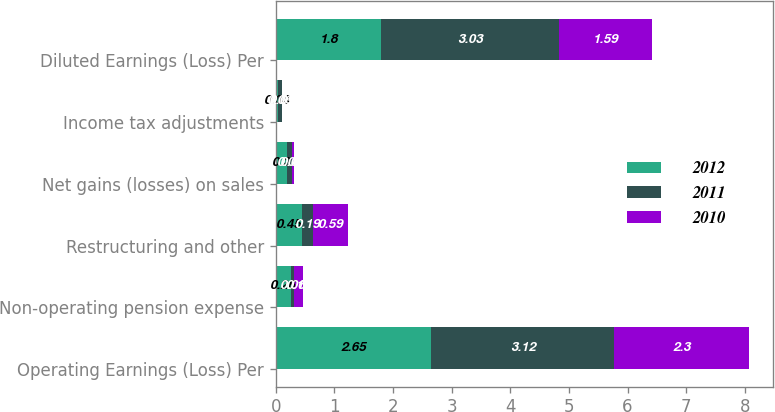<chart> <loc_0><loc_0><loc_500><loc_500><stacked_bar_chart><ecel><fcel>Operating Earnings (Loss) Per<fcel>Non-operating pension expense<fcel>Restructuring and other<fcel>Net gains (losses) on sales<fcel>Income tax adjustments<fcel>Diluted Earnings (Loss) Per<nl><fcel>2012<fcel>2.65<fcel>0.26<fcel>0.45<fcel>0.2<fcel>0.04<fcel>1.8<nl><fcel>2011<fcel>3.12<fcel>0.06<fcel>0.19<fcel>0.08<fcel>0.06<fcel>3.03<nl><fcel>2010<fcel>2.3<fcel>0.14<fcel>0.59<fcel>0.03<fcel>0.01<fcel>1.59<nl></chart> 